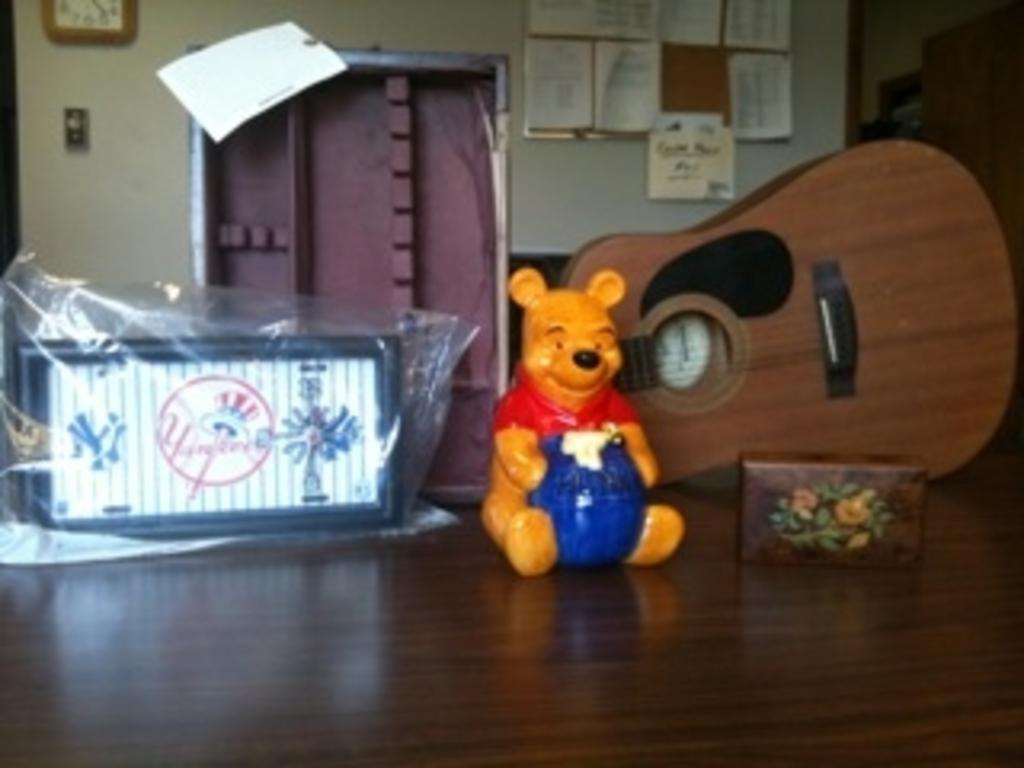What type of object can be seen in the image? There is a toy in the image. What musical instrument is present in the image? There is a guitar in the image. What container is visible in the image? There is a box in the image. What is on the table in the image? There is a photo frame on the table. What can be seen in the background of the image? There is a wall in the background of the image. What is attached to the wall in the image? There are notices and a clock on the wall. What architectural feature is present in the image? There is a door in the image. How many eyes can be seen on the toy in the image? There are no eyes visible on the toy in the image. What type of animals can be seen at the zoo in the image? There is no zoo present in the image. What is the sister doing in the image? There is no mention of a sister in the image or the provided facts. 